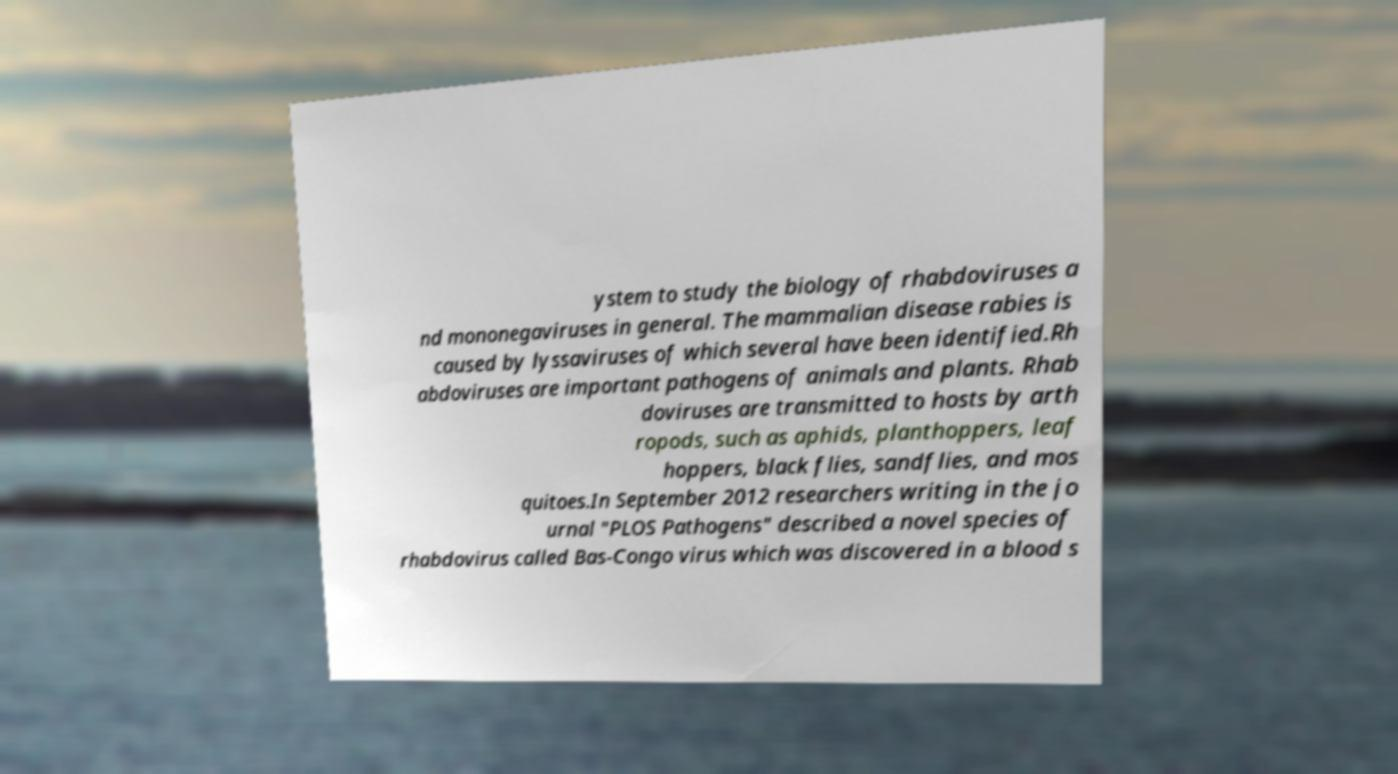Could you extract and type out the text from this image? ystem to study the biology of rhabdoviruses a nd mononegaviruses in general. The mammalian disease rabies is caused by lyssaviruses of which several have been identified.Rh abdoviruses are important pathogens of animals and plants. Rhab doviruses are transmitted to hosts by arth ropods, such as aphids, planthoppers, leaf hoppers, black flies, sandflies, and mos quitoes.In September 2012 researchers writing in the jo urnal "PLOS Pathogens" described a novel species of rhabdovirus called Bas-Congo virus which was discovered in a blood s 